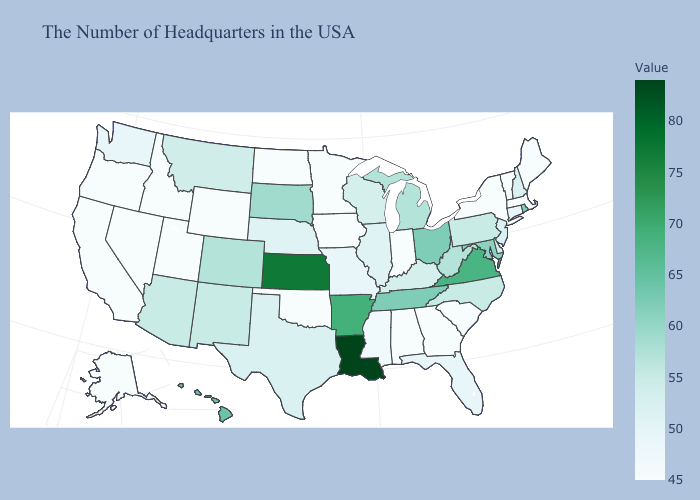Is the legend a continuous bar?
Short answer required. Yes. Does North Carolina have the highest value in the USA?
Keep it brief. No. Does Louisiana have the highest value in the South?
Write a very short answer. Yes. Among the states that border Nebraska , which have the highest value?
Answer briefly. Kansas. Does Nebraska have the highest value in the MidWest?
Quick response, please. No. Among the states that border Arkansas , which have the lowest value?
Give a very brief answer. Oklahoma. Does New York have the highest value in the USA?
Answer briefly. No. Does Kansas have the highest value in the MidWest?
Keep it brief. Yes. 